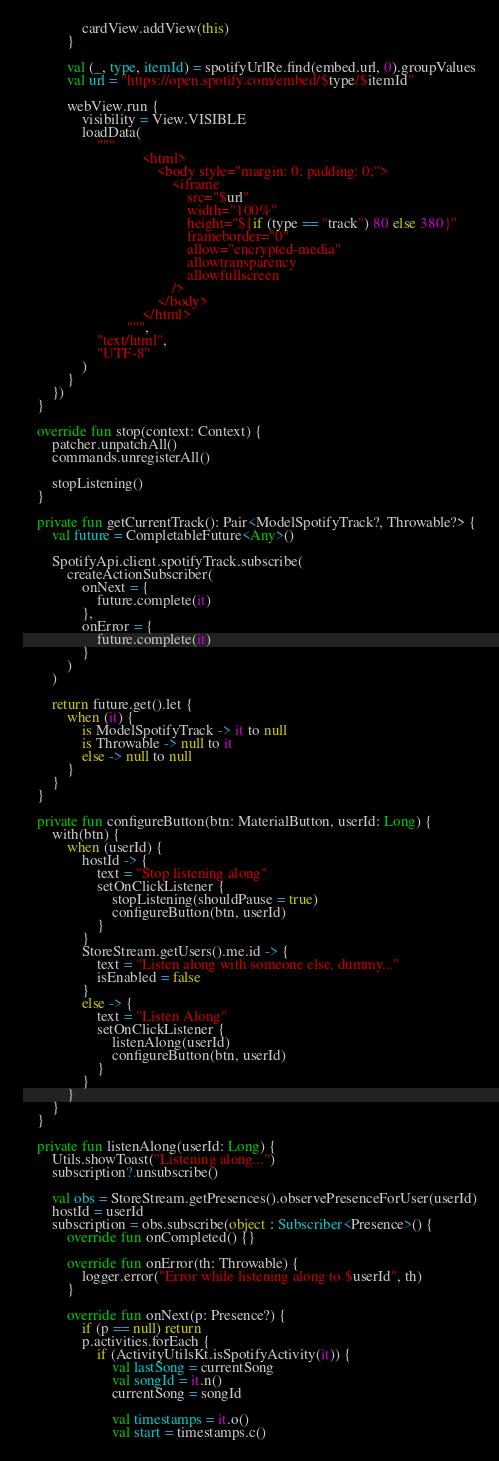Convert code to text. <code><loc_0><loc_0><loc_500><loc_500><_Kotlin_>                cardView.addView(this)
            }

            val (_, type, itemId) = spotifyUrlRe.find(embed.url, 0).groupValues
            val url = "https://open.spotify.com/embed/$type/$itemId"

            webView.run {
                visibility = View.VISIBLE
                loadData(
                    """
                                <html>
                                    <body style="margin: 0; padding: 0;">
                                        <iframe
                                            src="$url"
                                            width="100%"
                                            height="${if (type == "track") 80 else 380}"
                                            frameborder="0"
                                            allow="encrypted-media"
                                            allowtransparency
                                            allowfullscreen
                                        />
                                    </body>
                                </html>
                            """,
                    "text/html",
                    "UTF-8"
                )
            }
        })
    }

    override fun stop(context: Context) {
        patcher.unpatchAll()
        commands.unregisterAll()

        stopListening()
    }

    private fun getCurrentTrack(): Pair<ModelSpotifyTrack?, Throwable?> {
        val future = CompletableFuture<Any>()

        SpotifyApi.client.spotifyTrack.subscribe(
            createActionSubscriber(
                onNext = {
                    future.complete(it)
                },
                onError = {
                    future.complete(it)
                }
            )
        )

        return future.get().let {
            when (it) {
                is ModelSpotifyTrack -> it to null
                is Throwable -> null to it
                else -> null to null
            }
        }
    }

    private fun configureButton(btn: MaterialButton, userId: Long) {
        with(btn) {
            when (userId) {
                hostId -> {
                    text = "Stop listening along"
                    setOnClickListener {
                        stopListening(shouldPause = true)
                        configureButton(btn, userId)
                    }
                }
                StoreStream.getUsers().me.id -> {
                    text = "Listen along with someone else, dummy..."
                    isEnabled = false
                }
                else -> {
                    text = "Listen Along"
                    setOnClickListener {
                        listenAlong(userId)
                        configureButton(btn, userId)
                    }
                }
            }
        }
    }

    private fun listenAlong(userId: Long) {
        Utils.showToast("Listening along...")
        subscription?.unsubscribe()

        val obs = StoreStream.getPresences().observePresenceForUser(userId)
        hostId = userId
        subscription = obs.subscribe(object : Subscriber<Presence>() {
            override fun onCompleted() {}

            override fun onError(th: Throwable) {
                logger.error("Error while listening along to $userId", th)
            }

            override fun onNext(p: Presence?) {
                if (p == null) return
                p.activities.forEach {
                    if (ActivityUtilsKt.isSpotifyActivity(it)) {
                        val lastSong = currentSong
                        val songId = it.n()
                        currentSong = songId

                        val timestamps = it.o()
                        val start = timestamps.c()</code> 